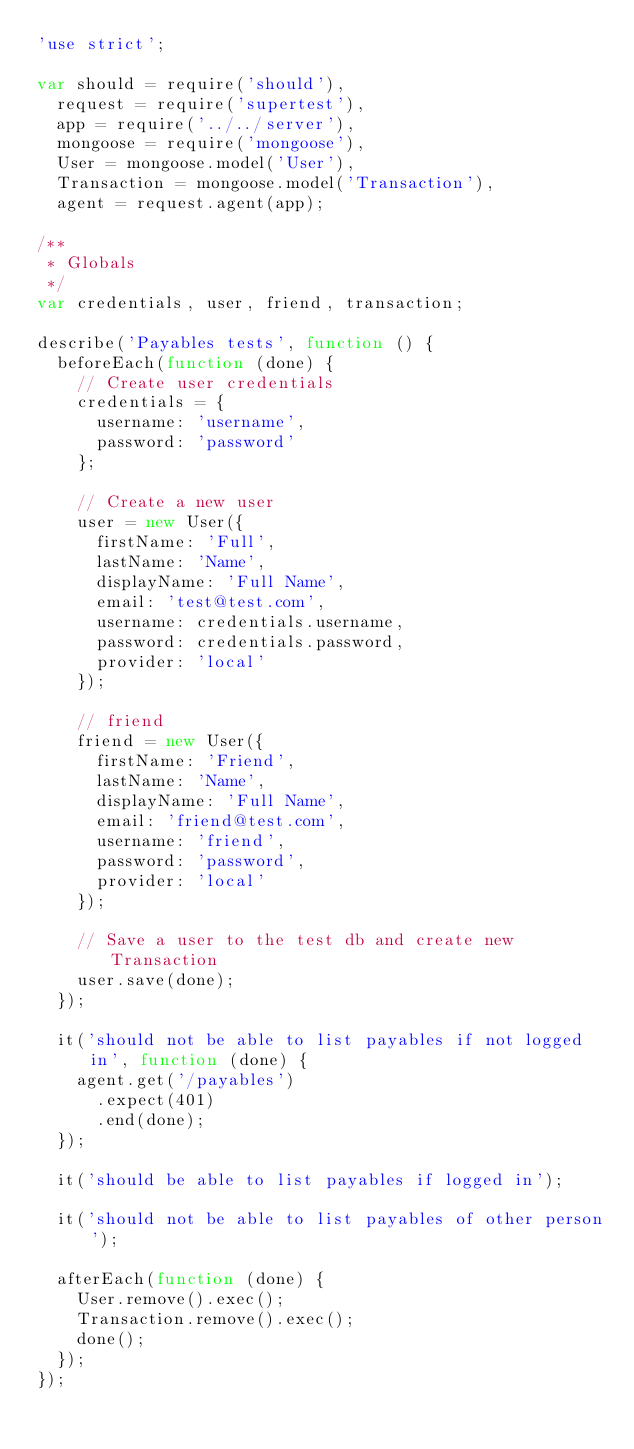<code> <loc_0><loc_0><loc_500><loc_500><_JavaScript_>'use strict';

var should = require('should'),
  request = require('supertest'),
  app = require('../../server'),
  mongoose = require('mongoose'),
  User = mongoose.model('User'),
  Transaction = mongoose.model('Transaction'),
  agent = request.agent(app);

/**
 * Globals
 */
var credentials, user, friend, transaction;

describe('Payables tests', function () {
  beforeEach(function (done) {
    // Create user credentials
    credentials = {
      username: 'username',
      password: 'password'
    };

    // Create a new user
    user = new User({
      firstName: 'Full',
      lastName: 'Name',
      displayName: 'Full Name',
      email: 'test@test.com',
      username: credentials.username,
      password: credentials.password,
      provider: 'local'
    });

    // friend
    friend = new User({
      firstName: 'Friend',
      lastName: 'Name',
      displayName: 'Full Name',
      email: 'friend@test.com',
      username: 'friend',
      password: 'password',
      provider: 'local'
    });

    // Save a user to the test db and create new Transaction
    user.save(done);
  });

  it('should not be able to list payables if not logged in', function (done) {
    agent.get('/payables')
      .expect(401)
      .end(done);
  });

  it('should be able to list payables if logged in');

  it('should not be able to list payables of other person');

  afterEach(function (done) {
    User.remove().exec();
    Transaction.remove().exec();
    done();
  });
});


</code> 